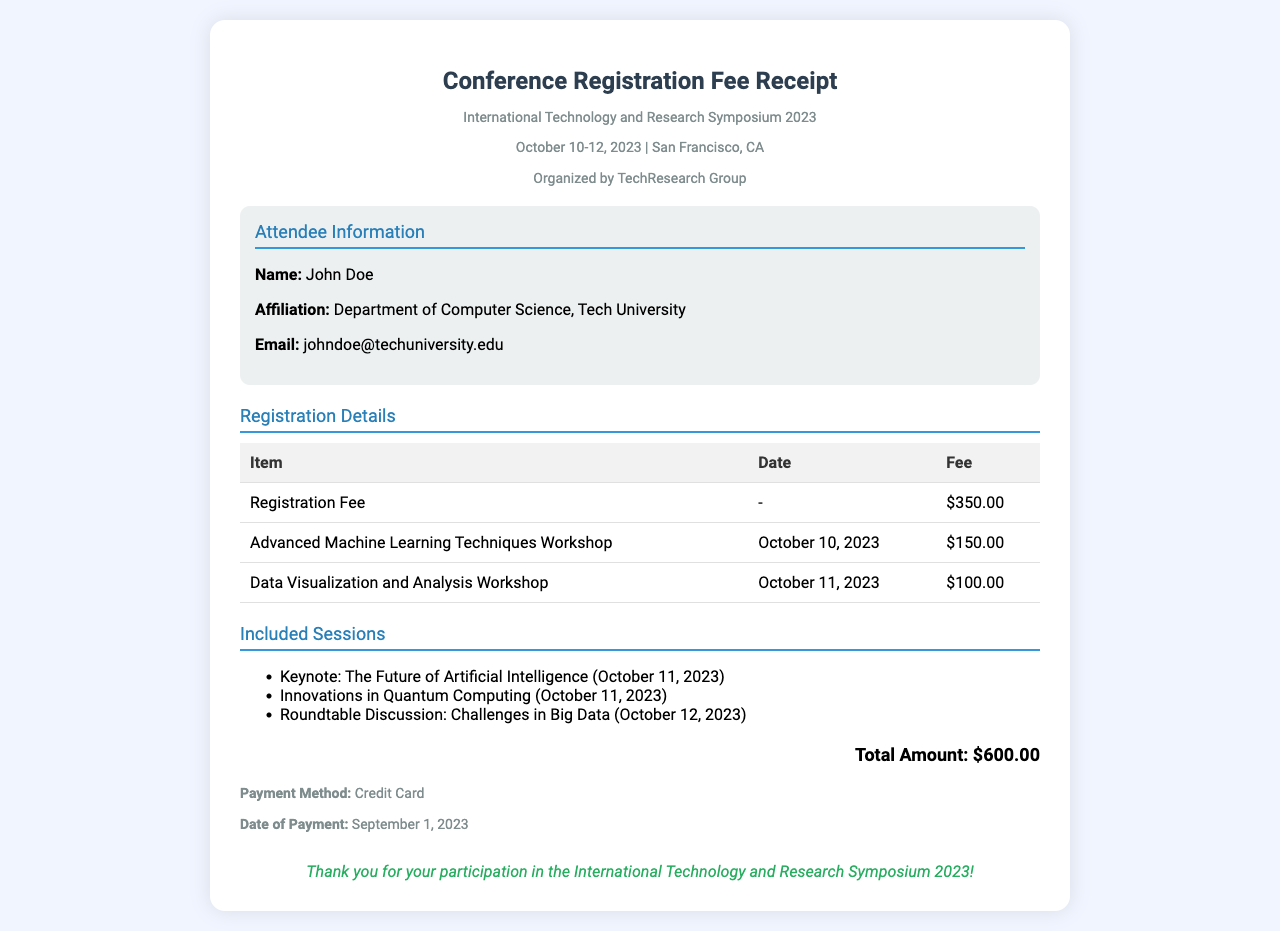What is the total amount? The total amount is listed at the end of the receipt, which sums up all fees.
Answer: $600.00 Who is the attendee? The attendee's name is presented in the attendee information section.
Answer: John Doe What is the affiliation of the attendee? The affiliation is specified right under the attendee's name in the information section.
Answer: Department of Computer Science, Tech University What date did the workshop on Advanced Machine Learning Techniques occur? The date is provided in the registration details table under the respective workshop.
Answer: October 10, 2023 How much was the registration fee? The registration fee is listed as a separate entry in the registration details table.
Answer: $350.00 Which session is included on October 12, 2023? The included sessions section lists sessions with their respective dates.
Answer: Roundtable Discussion: Challenges in Big Data What payment method was used? The payment method is included in the payment information section of the receipt.
Answer: Credit Card How many workshops did the attendee participate in? The number of workshops can be counted from the registration details table.
Answer: 2 What organization hosted the symposium? The organization is mentioned in the header section of the receipt.
Answer: TechResearch Group 